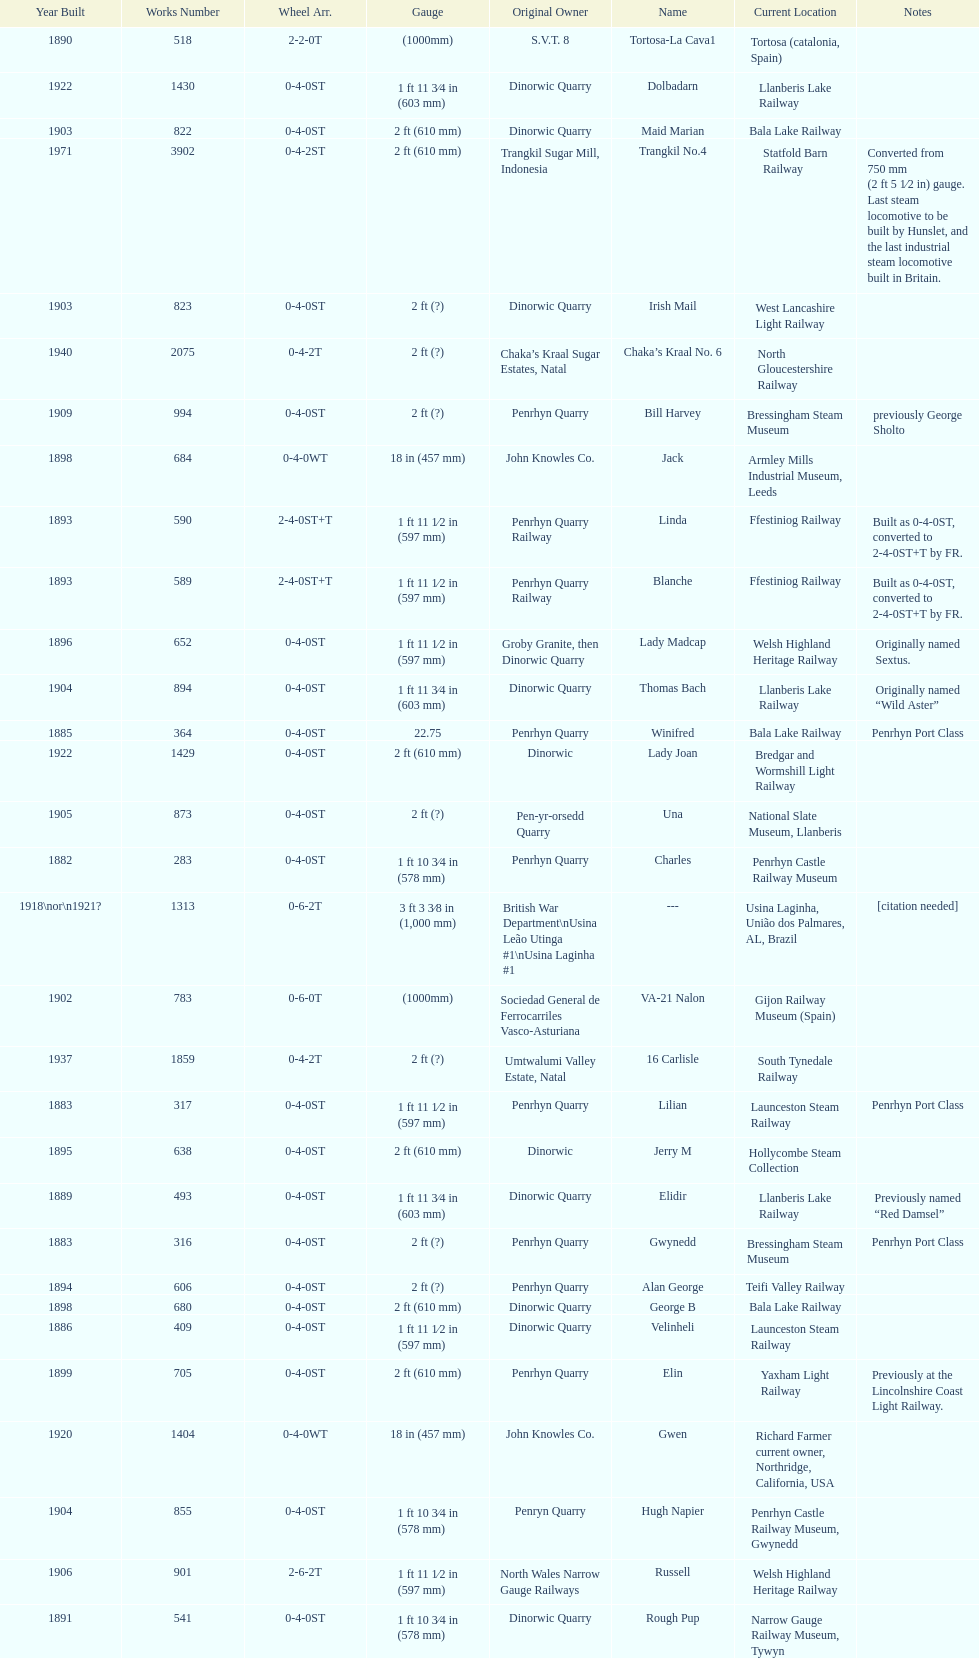What is the name of the last locomotive to be located at the bressingham steam museum? Gwynedd. 